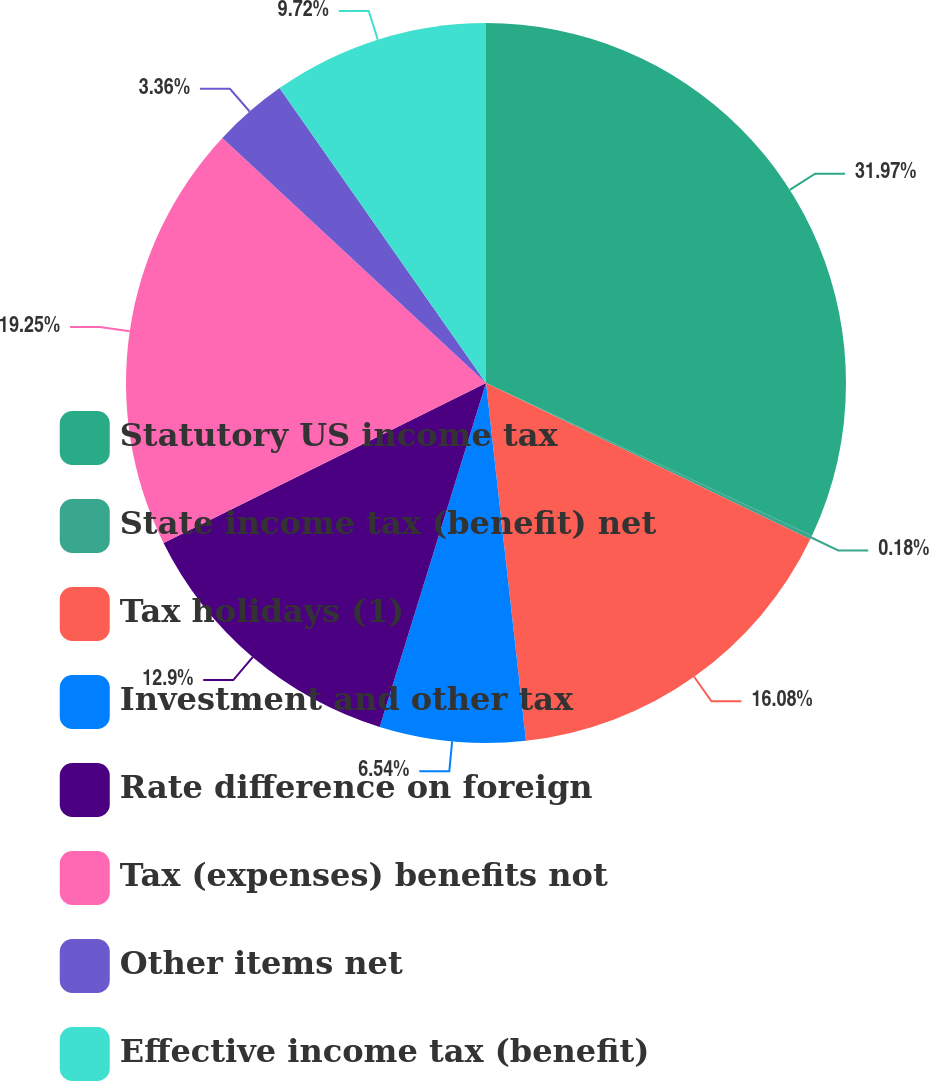Convert chart to OTSL. <chart><loc_0><loc_0><loc_500><loc_500><pie_chart><fcel>Statutory US income tax<fcel>State income tax (benefit) net<fcel>Tax holidays (1)<fcel>Investment and other tax<fcel>Rate difference on foreign<fcel>Tax (expenses) benefits not<fcel>Other items net<fcel>Effective income tax (benefit)<nl><fcel>31.97%<fcel>0.18%<fcel>16.08%<fcel>6.54%<fcel>12.9%<fcel>19.25%<fcel>3.36%<fcel>9.72%<nl></chart> 